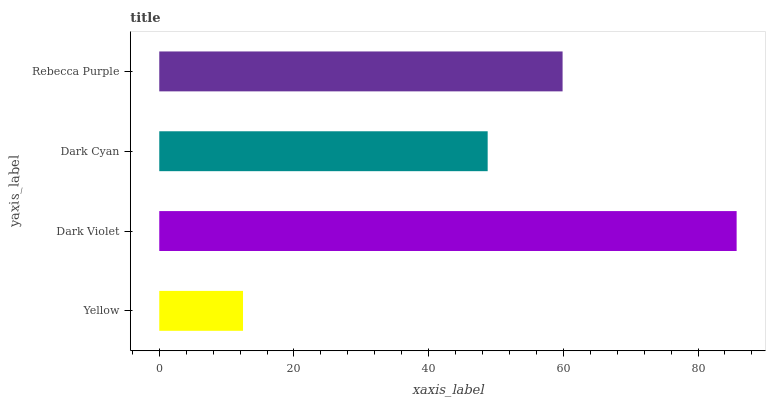Is Yellow the minimum?
Answer yes or no. Yes. Is Dark Violet the maximum?
Answer yes or no. Yes. Is Dark Cyan the minimum?
Answer yes or no. No. Is Dark Cyan the maximum?
Answer yes or no. No. Is Dark Violet greater than Dark Cyan?
Answer yes or no. Yes. Is Dark Cyan less than Dark Violet?
Answer yes or no. Yes. Is Dark Cyan greater than Dark Violet?
Answer yes or no. No. Is Dark Violet less than Dark Cyan?
Answer yes or no. No. Is Rebecca Purple the high median?
Answer yes or no. Yes. Is Dark Cyan the low median?
Answer yes or no. Yes. Is Yellow the high median?
Answer yes or no. No. Is Yellow the low median?
Answer yes or no. No. 